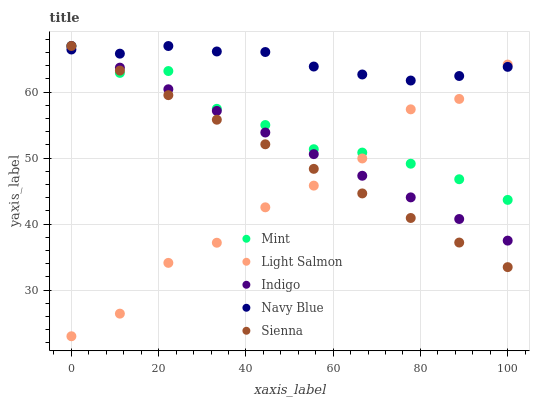Does Light Salmon have the minimum area under the curve?
Answer yes or no. Yes. Does Navy Blue have the maximum area under the curve?
Answer yes or no. Yes. Does Indigo have the minimum area under the curve?
Answer yes or no. No. Does Indigo have the maximum area under the curve?
Answer yes or no. No. Is Indigo the smoothest?
Answer yes or no. Yes. Is Light Salmon the roughest?
Answer yes or no. Yes. Is Light Salmon the smoothest?
Answer yes or no. No. Is Indigo the roughest?
Answer yes or no. No. Does Light Salmon have the lowest value?
Answer yes or no. Yes. Does Indigo have the lowest value?
Answer yes or no. No. Does Navy Blue have the highest value?
Answer yes or no. Yes. Does Light Salmon have the highest value?
Answer yes or no. No. Does Indigo intersect Sienna?
Answer yes or no. Yes. Is Indigo less than Sienna?
Answer yes or no. No. Is Indigo greater than Sienna?
Answer yes or no. No. 